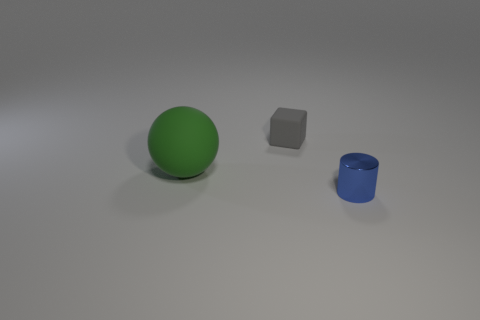Add 2 small blue rubber things. How many objects exist? 5 Subtract all cylinders. How many objects are left? 2 Subtract 0 purple cubes. How many objects are left? 3 Subtract all tiny yellow matte blocks. Subtract all gray matte blocks. How many objects are left? 2 Add 1 big matte spheres. How many big matte spheres are left? 2 Add 2 small blue metal cylinders. How many small blue metal cylinders exist? 3 